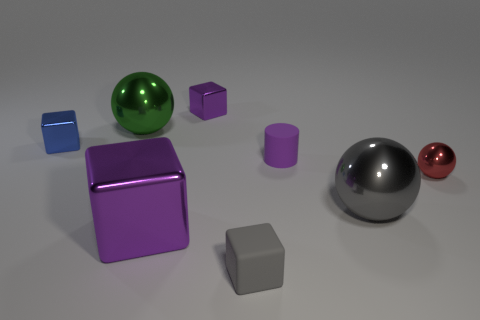Add 1 red shiny things. How many objects exist? 9 Subtract all tiny cubes. How many cubes are left? 1 Subtract all red balls. How many balls are left? 2 Subtract 0 cyan cylinders. How many objects are left? 8 Subtract all balls. How many objects are left? 5 Subtract 1 cylinders. How many cylinders are left? 0 Subtract all purple blocks. Subtract all yellow cylinders. How many blocks are left? 2 Subtract all brown cylinders. How many purple blocks are left? 2 Subtract all small purple shiny cubes. Subtract all gray objects. How many objects are left? 5 Add 2 big balls. How many big balls are left? 4 